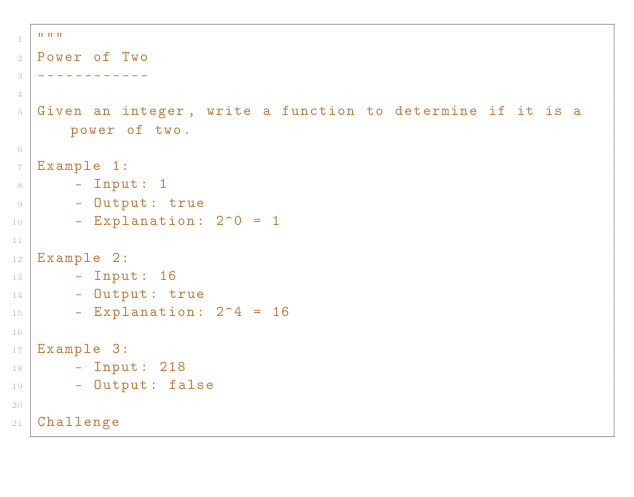Convert code to text. <code><loc_0><loc_0><loc_500><loc_500><_Python_>"""
Power of Two
------------

Given an integer, write a function to determine if it is a power of two.

Example 1:
    - Input: 1
    - Output: true
    - Explanation: 2^0 = 1

Example 2:
    - Input: 16
    - Output: true
    - Explanation: 2^4 = 16

Example 3:
    - Input: 218
    - Output: false

Challenge</code> 